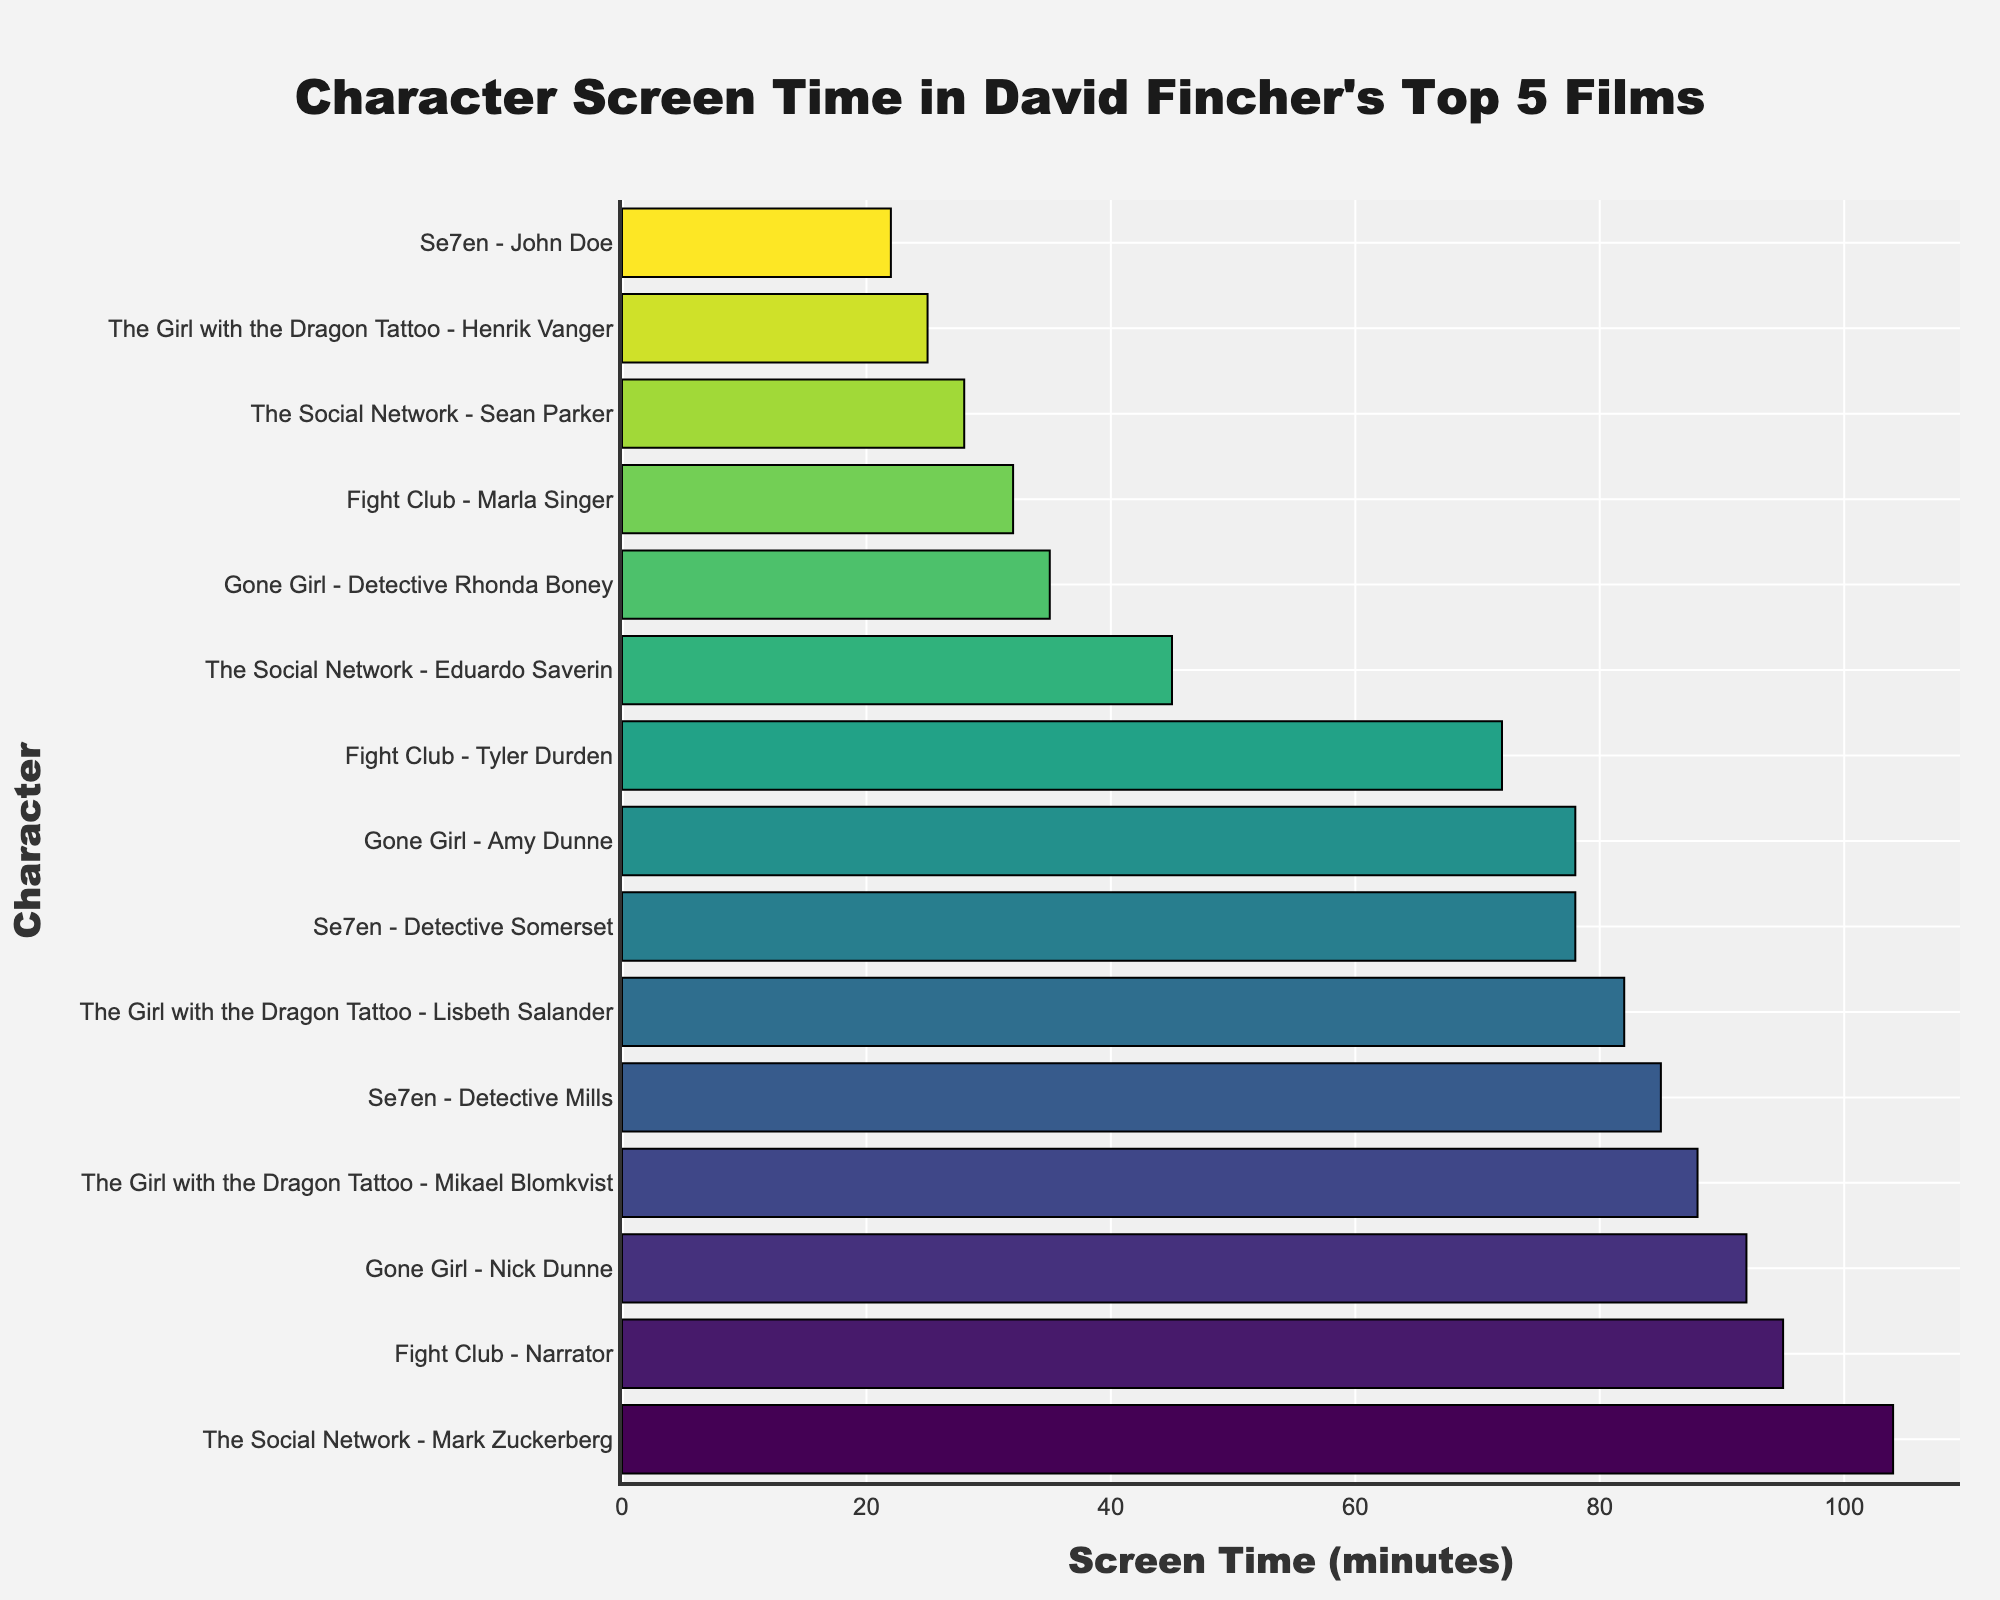What is the screen time difference between Mark Zuckerberg in "The Social Network" and the Narrator in "Fight Club"? Mark Zuckerberg's screen time is 104 minutes, and the Narrator's is 95 minutes. The difference is calculated as 104 - 95
Answer: 9 minutes Which character has the highest screen time in the dataset? By examining the bar chart, the character with the highest screen time is Mark Zuckerberg from "The Social Network," with 104 minutes
Answer: Mark Zuckerberg Compare the screen times of Amy Dunne and Detective Somerset. Who has more screen time and by how much? Amy Dunne has 78 minutes, and Detective Somerset has 78 minutes as well. Since their screen times are equal
Answer: Neither, the same screen time What is the sum of the screen times of all characters in "Fight Club"? Summing the screen times of the Narrator (95), Tyler Durden (72), and Marla Singer (32), we get 95 + 72 + 32 = 199 minutes
Answer: 199 minutes Which film has the most cumulative screen time of its main characters? The characters' screen times for each film are sum up: 
Se7en (Detective Mills: 85, Detective Somerset: 78, John Doe: 22) = 85 + 78 + 22 = 185;
Fight Club (Narrator: 95, Tyler Durden: 72, Marla Singer: 32) = 95 + 72 + 32 = 199;
The Social Network (Mark Zuckerberg: 104, Eduardo Saverin: 45, Sean Parker: 28) = 104 + 45 + 28 = 177;
Gone Girl (Nick Dunne: 92, Amy Dunne: 78, Detective Rhonda Boney: 35) = 92 + 78 + 35 = 205;
The Girl with the Dragon Tattoo (Mikael Blomkvist: 88, Lisbeth Salander: 82, Henrik Vanger: 25) = 88 + 82 + 25 = 195.
The film with the most cumulative screen time is "Gone Girl" with 205 minutes
Answer: Gone Girl What is the average screen time of the characters in "The Girl with the Dragon Tattoo"? The screen times for the characters Mikael Blomkvist, Lisbeth Salander, and Henrik Vanger are 88, 82, and 25 respectively. The average screen time is calculated as (88 + 82 + 25) / 3 = 65 minutes
Answer: 65 minutes Arrange the characters from "Se7en" by their screen time in descending order Detective Mills has 85 minutes, Detective Somerset has 78 minutes, and John Doe has 22 minutes. From highest to lowest, the order is Detective Mills, Detective Somerset, John Doe
Answer: Detective Mills, Detective Somerset, John Doe Are there any characters whose screen times are under 30 minutes? By referring to the figure, John Doe (22 minutes), Sean Parker (28 minutes), and Henrik Vanger (25 minutes) have screen times under 30 minutes
Answer: Yes, three characters 